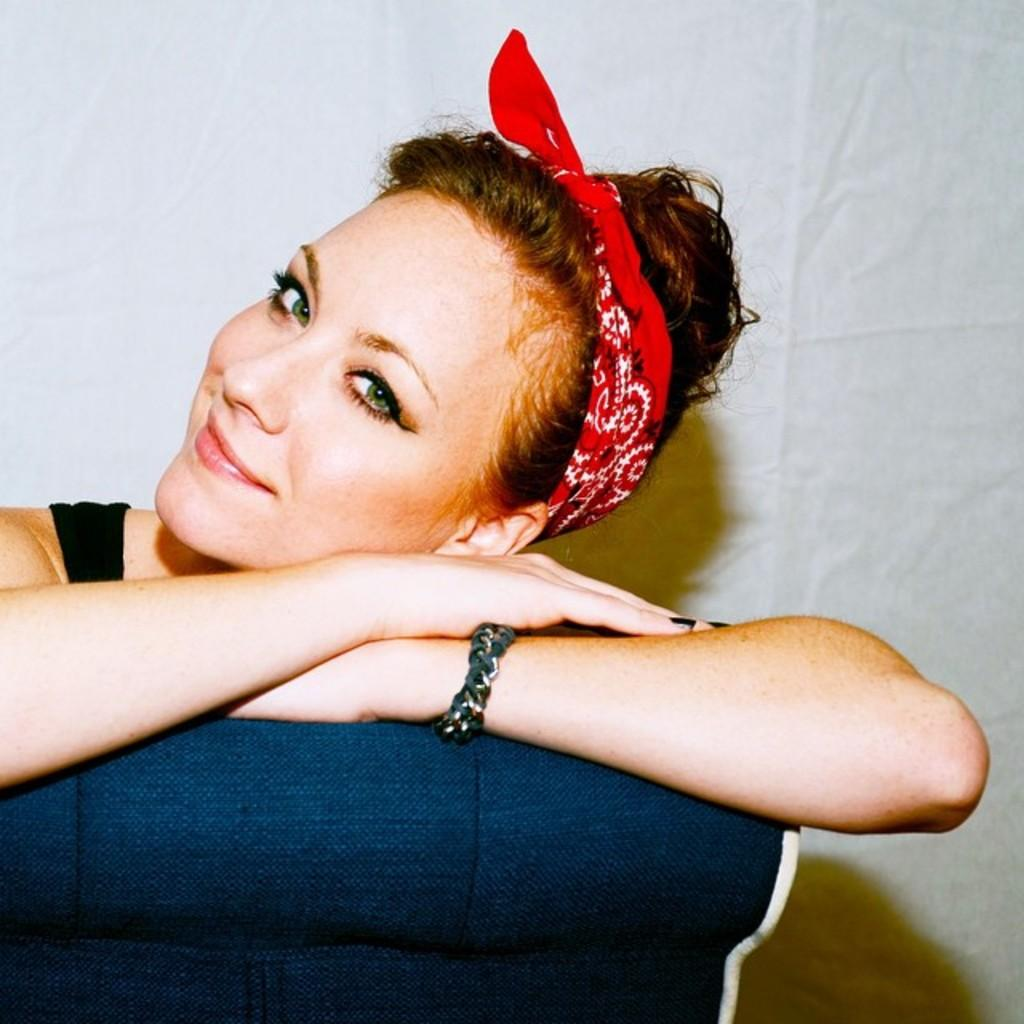Who is present in the image? There is a woman in the image. What is the woman doing in the image? The woman is smiling in the image. What is the woman sitting on in the image? The woman is sitting on a violet color object. What color is the background of the image? The background of the image is white in color. Can you see any clovers in the image? There are no clovers present in the image. What phase of the moon is visible in the image? The image does not depict the moon, so it is not possible to determine its phase. 